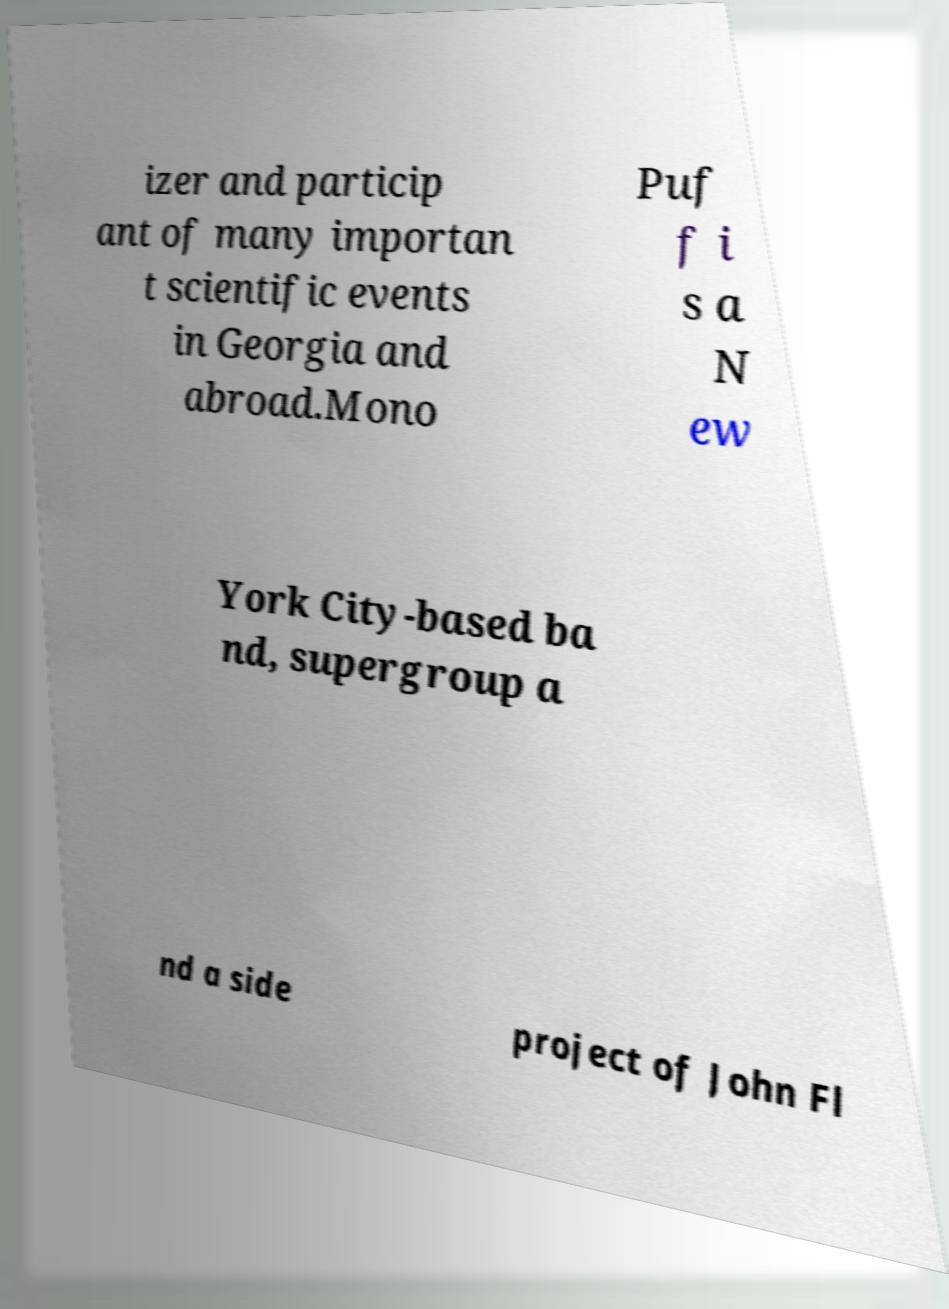Please read and relay the text visible in this image. What does it say? izer and particip ant of many importan t scientific events in Georgia and abroad.Mono Puf f i s a N ew York City-based ba nd, supergroup a nd a side project of John Fl 